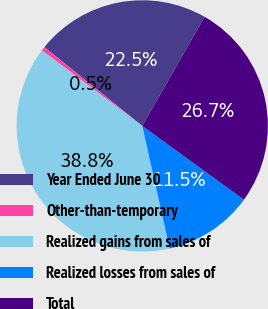Convert chart. <chart><loc_0><loc_0><loc_500><loc_500><pie_chart><fcel>Year Ended June 30<fcel>Other-than-temporary<fcel>Realized gains from sales of<fcel>Realized losses from sales of<fcel>Total<nl><fcel>22.49%<fcel>0.52%<fcel>38.76%<fcel>11.5%<fcel>26.73%<nl></chart> 